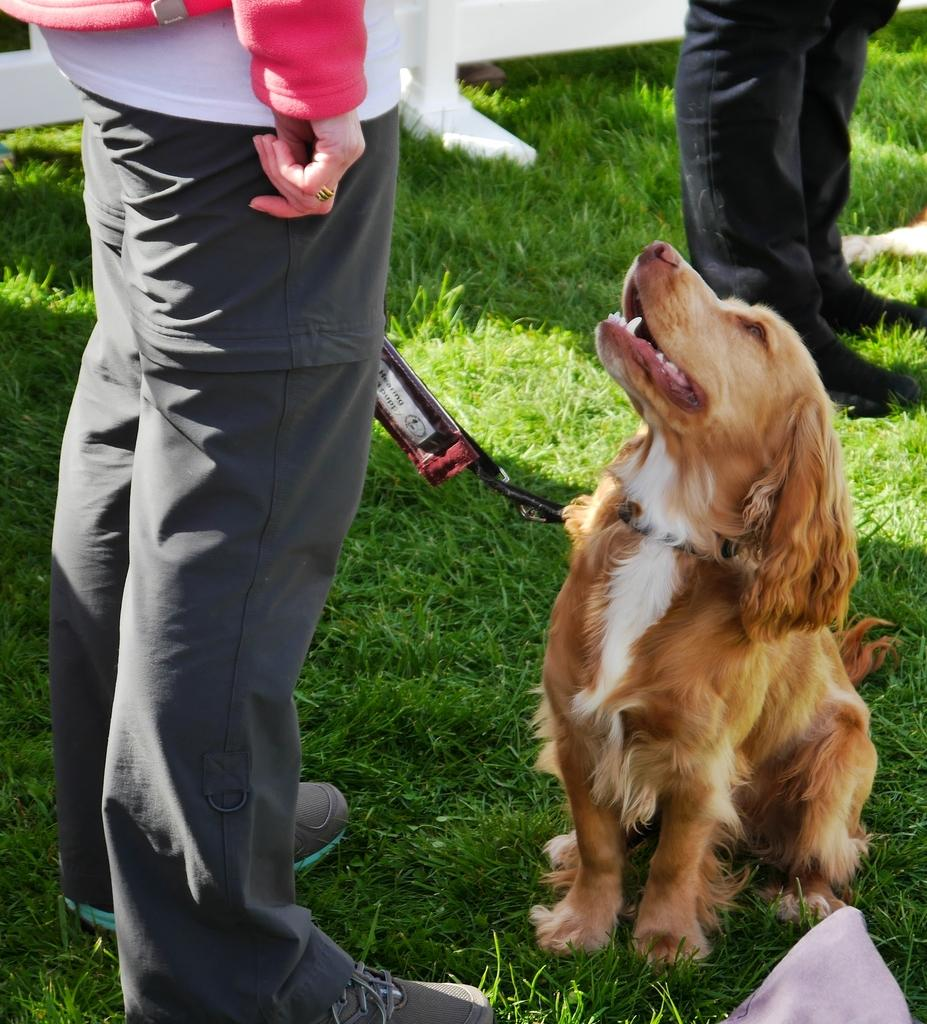How many people are in the image? There are two persons in the image. What is the setting of the image? The persons are standing on a grass field. What is the person holding in the image? One person is holding a dog with its leash. What can be seen in the background of the image? There is a wooden fence in the background of the image. What is the position of the person's lip in the image? There is no information about the position of the person's lip in the image, as the facts provided do not mention any facial features. 